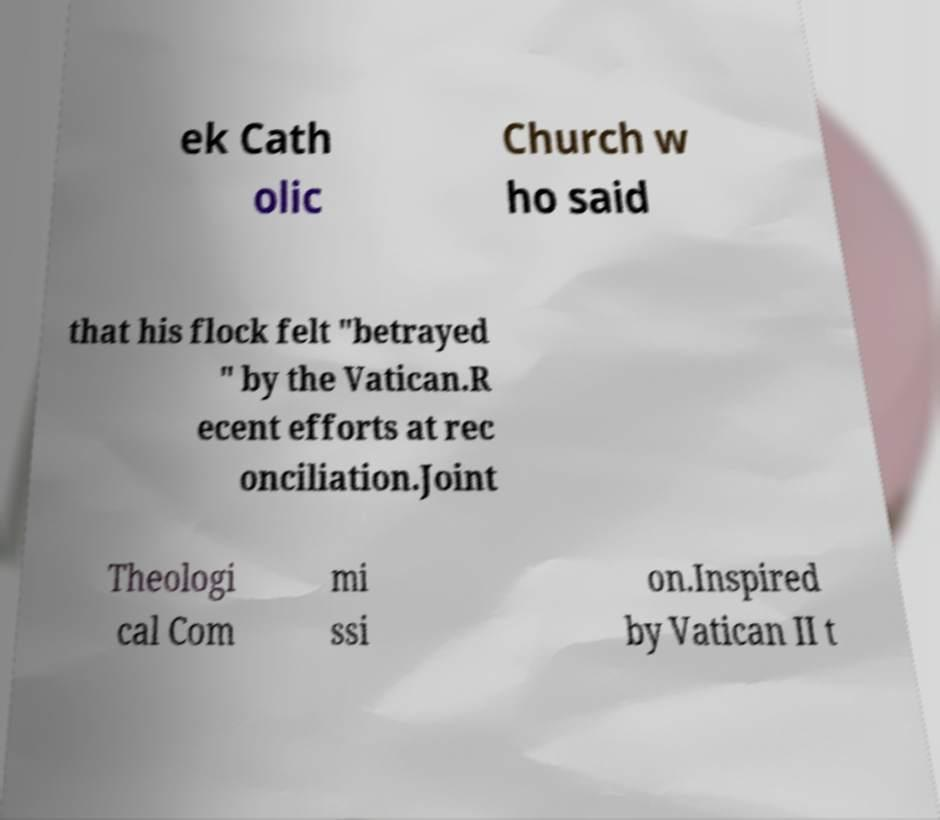Please read and relay the text visible in this image. What does it say? ek Cath olic Church w ho said that his flock felt "betrayed " by the Vatican.R ecent efforts at rec onciliation.Joint Theologi cal Com mi ssi on.Inspired by Vatican II t 